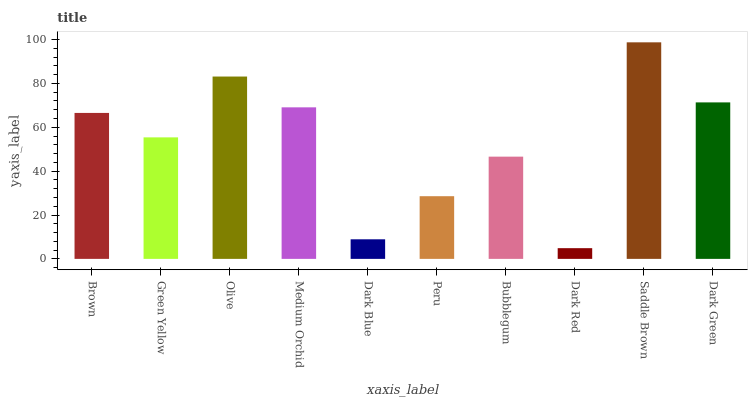Is Dark Red the minimum?
Answer yes or no. Yes. Is Saddle Brown the maximum?
Answer yes or no. Yes. Is Green Yellow the minimum?
Answer yes or no. No. Is Green Yellow the maximum?
Answer yes or no. No. Is Brown greater than Green Yellow?
Answer yes or no. Yes. Is Green Yellow less than Brown?
Answer yes or no. Yes. Is Green Yellow greater than Brown?
Answer yes or no. No. Is Brown less than Green Yellow?
Answer yes or no. No. Is Brown the high median?
Answer yes or no. Yes. Is Green Yellow the low median?
Answer yes or no. Yes. Is Olive the high median?
Answer yes or no. No. Is Bubblegum the low median?
Answer yes or no. No. 